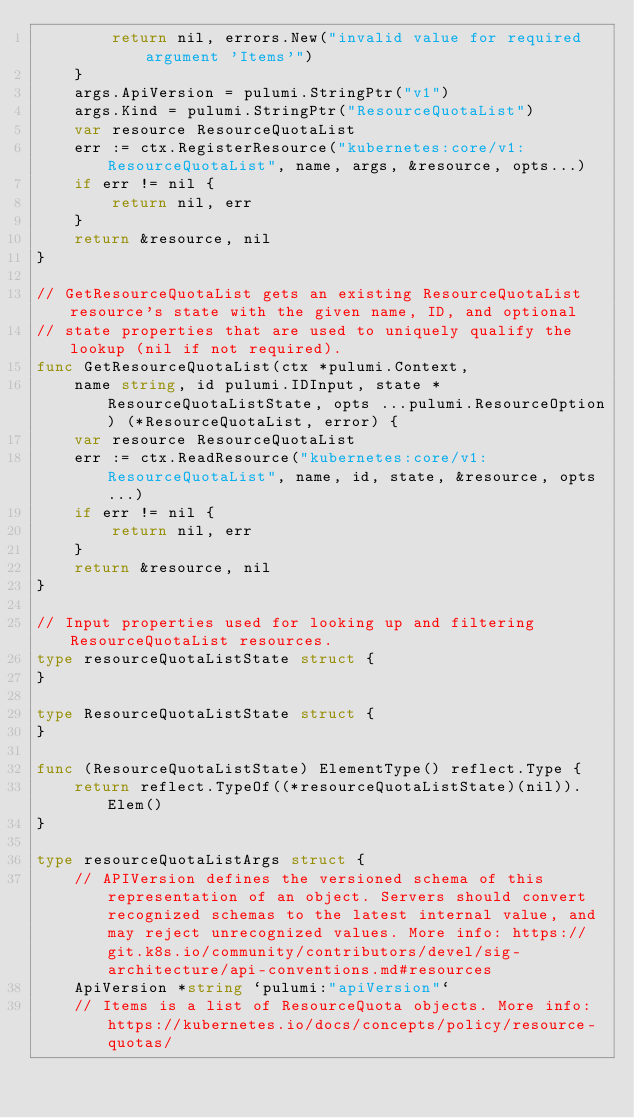Convert code to text. <code><loc_0><loc_0><loc_500><loc_500><_Go_>		return nil, errors.New("invalid value for required argument 'Items'")
	}
	args.ApiVersion = pulumi.StringPtr("v1")
	args.Kind = pulumi.StringPtr("ResourceQuotaList")
	var resource ResourceQuotaList
	err := ctx.RegisterResource("kubernetes:core/v1:ResourceQuotaList", name, args, &resource, opts...)
	if err != nil {
		return nil, err
	}
	return &resource, nil
}

// GetResourceQuotaList gets an existing ResourceQuotaList resource's state with the given name, ID, and optional
// state properties that are used to uniquely qualify the lookup (nil if not required).
func GetResourceQuotaList(ctx *pulumi.Context,
	name string, id pulumi.IDInput, state *ResourceQuotaListState, opts ...pulumi.ResourceOption) (*ResourceQuotaList, error) {
	var resource ResourceQuotaList
	err := ctx.ReadResource("kubernetes:core/v1:ResourceQuotaList", name, id, state, &resource, opts...)
	if err != nil {
		return nil, err
	}
	return &resource, nil
}

// Input properties used for looking up and filtering ResourceQuotaList resources.
type resourceQuotaListState struct {
}

type ResourceQuotaListState struct {
}

func (ResourceQuotaListState) ElementType() reflect.Type {
	return reflect.TypeOf((*resourceQuotaListState)(nil)).Elem()
}

type resourceQuotaListArgs struct {
	// APIVersion defines the versioned schema of this representation of an object. Servers should convert recognized schemas to the latest internal value, and may reject unrecognized values. More info: https://git.k8s.io/community/contributors/devel/sig-architecture/api-conventions.md#resources
	ApiVersion *string `pulumi:"apiVersion"`
	// Items is a list of ResourceQuota objects. More info: https://kubernetes.io/docs/concepts/policy/resource-quotas/</code> 